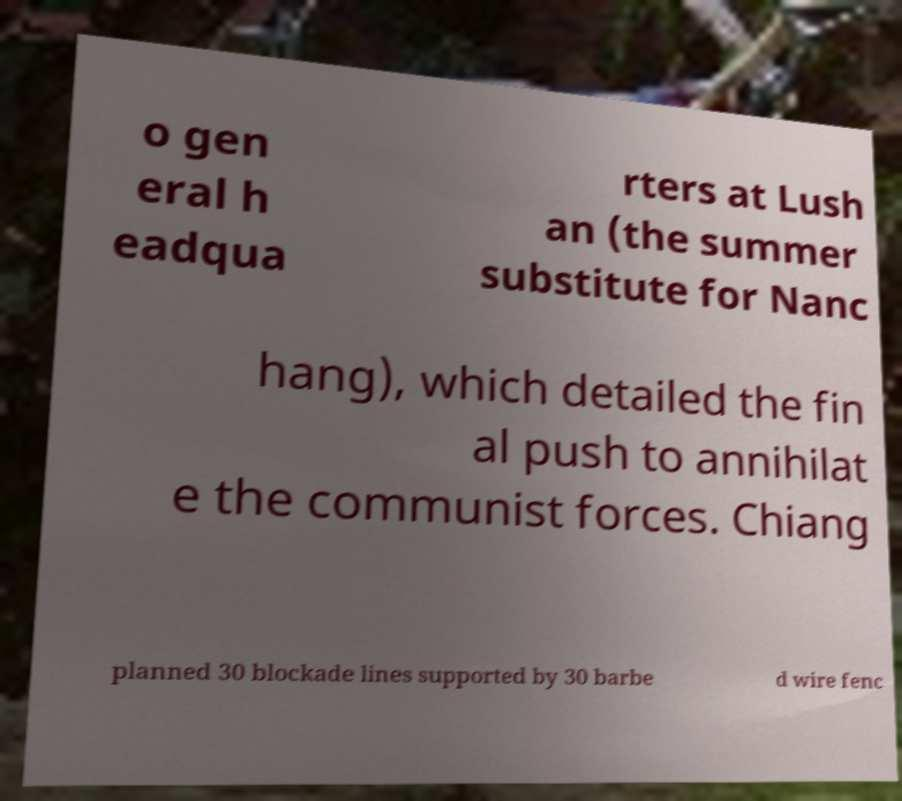I need the written content from this picture converted into text. Can you do that? o gen eral h eadqua rters at Lush an (the summer substitute for Nanc hang), which detailed the fin al push to annihilat e the communist forces. Chiang planned 30 blockade lines supported by 30 barbe d wire fenc 